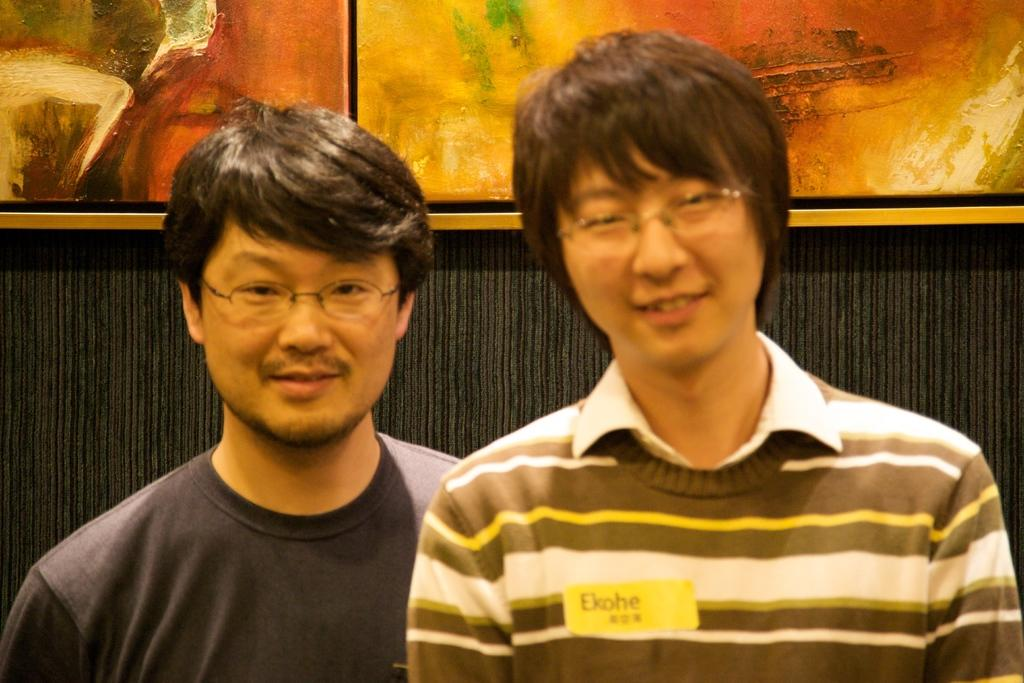How many people are in the image? There are persons standing in the image. What is the facial expression of the persons in the image? The persons are smiling. What can be seen in the background of the image? There is a wall visible in the background of the image. What is attached to the wall in the image? There are painting boards attached to the wall. Can you hear the mother coughing in the image? There is no mention of a mother or any sound in the image, so it cannot be determined if someone is coughing. 